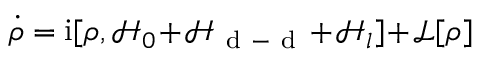<formula> <loc_0><loc_0><loc_500><loc_500>\dot { \rho } = i [ \rho , \mathcal { H } _ { 0 } \, + \, \mathcal { H } _ { d - d } \, + \, \mathcal { H } _ { l } ] \, + \, \mathcal { L } [ \rho ]</formula> 